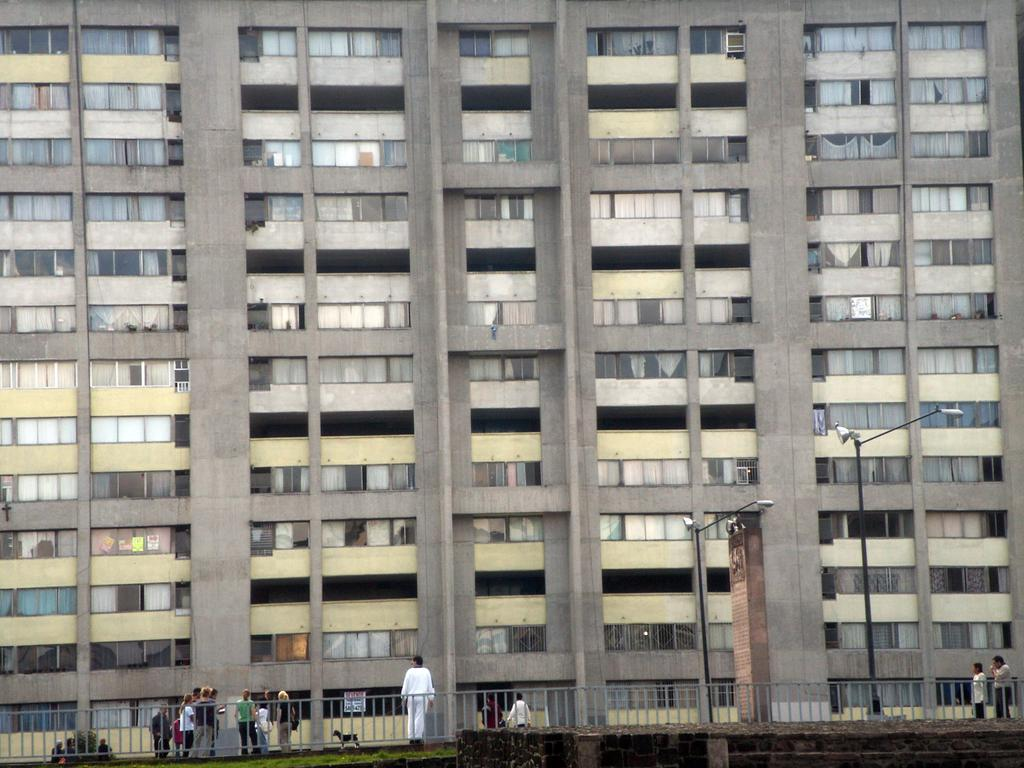What is the main structure in the image? There is a big building in the image. What feature can be seen on the building? The building has windows. What is located in front of the building? There is a road in front of the building. What are the people in the image doing? People are standing on the road. What other objects can be seen in the image? There is fencing and poles in the image. Can you see any poisonous trees in the image? There are no trees mentioned or visible in the image, let alone poisonous ones. What type of pump is used to power the building in the image? There is no pump present in the image, and the source of power for the building is not mentioned. 